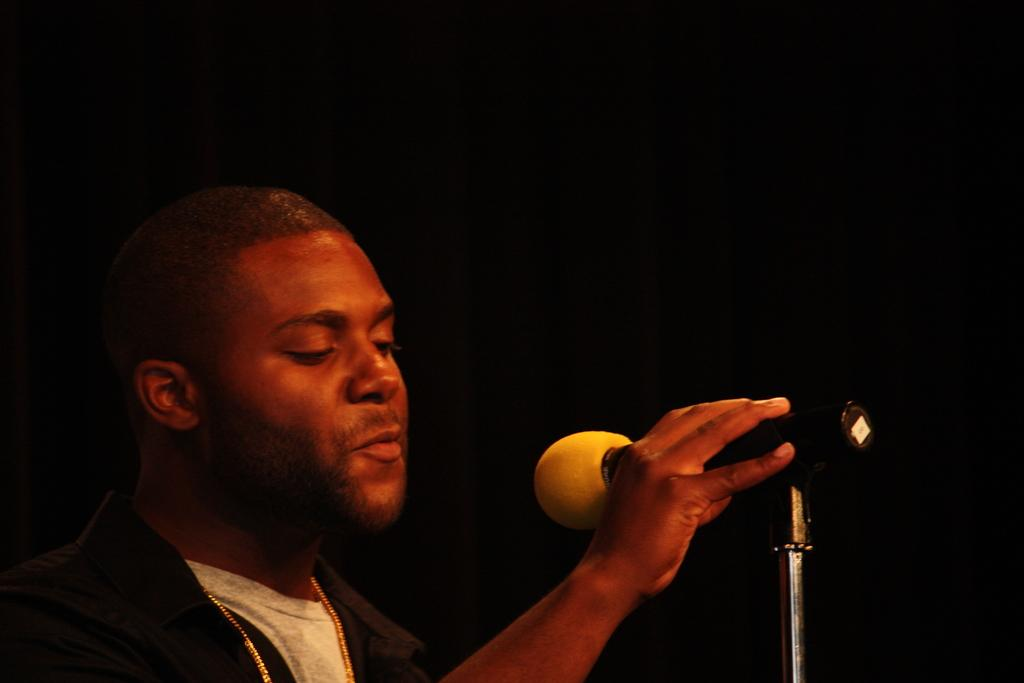What is the main subject of the image? There is a person in the image. What is the person holding in his hand? The person is holding a microphone in his hand. What type of religious ceremony is the person participating in with the quince in the image? There is no religious ceremony or quince present in the image; it only features a person holding a microphone. 